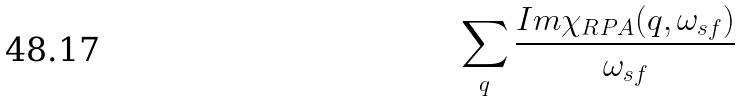Convert formula to latex. <formula><loc_0><loc_0><loc_500><loc_500>\sum _ { q } \frac { I m \chi _ { R P A } ( { q } , \omega _ { s f } ) } { \omega _ { s f } }</formula> 